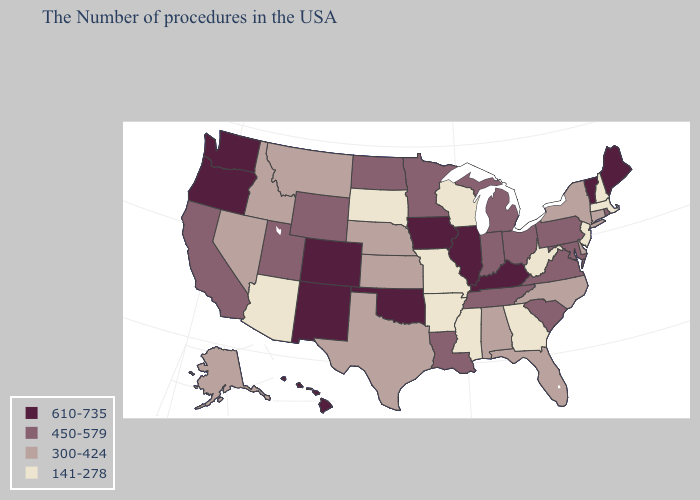What is the highest value in the West ?
Short answer required. 610-735. Does the map have missing data?
Quick response, please. No. Name the states that have a value in the range 300-424?
Answer briefly. Connecticut, New York, Delaware, North Carolina, Florida, Alabama, Kansas, Nebraska, Texas, Montana, Idaho, Nevada, Alaska. Which states hav the highest value in the MidWest?
Quick response, please. Illinois, Iowa. Does South Dakota have the highest value in the USA?
Quick response, please. No. What is the lowest value in states that border Arizona?
Write a very short answer. 300-424. Which states hav the highest value in the MidWest?
Short answer required. Illinois, Iowa. What is the value of Utah?
Concise answer only. 450-579. Which states have the lowest value in the MidWest?
Quick response, please. Wisconsin, Missouri, South Dakota. Name the states that have a value in the range 141-278?
Answer briefly. Massachusetts, New Hampshire, New Jersey, West Virginia, Georgia, Wisconsin, Mississippi, Missouri, Arkansas, South Dakota, Arizona. What is the value of South Carolina?
Quick response, please. 450-579. Among the states that border Ohio , does Kentucky have the highest value?
Be succinct. Yes. What is the lowest value in the USA?
Concise answer only. 141-278. What is the value of New Hampshire?
Concise answer only. 141-278. What is the value of Kansas?
Keep it brief. 300-424. 